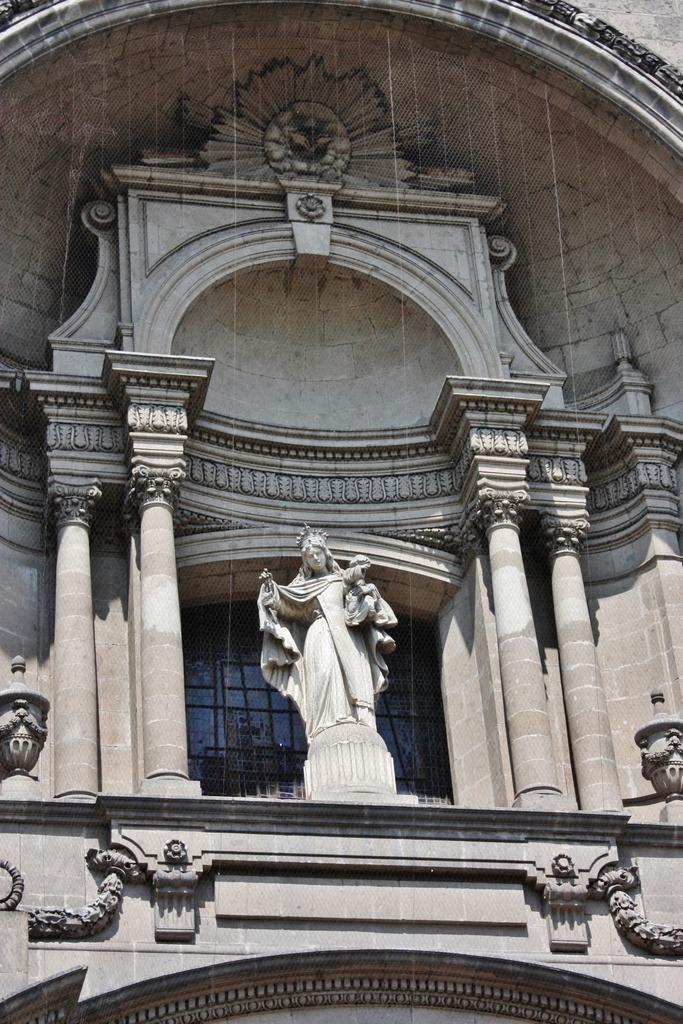Describe this image in one or two sentences. In this image, we can see a statue and there are some pillars. 